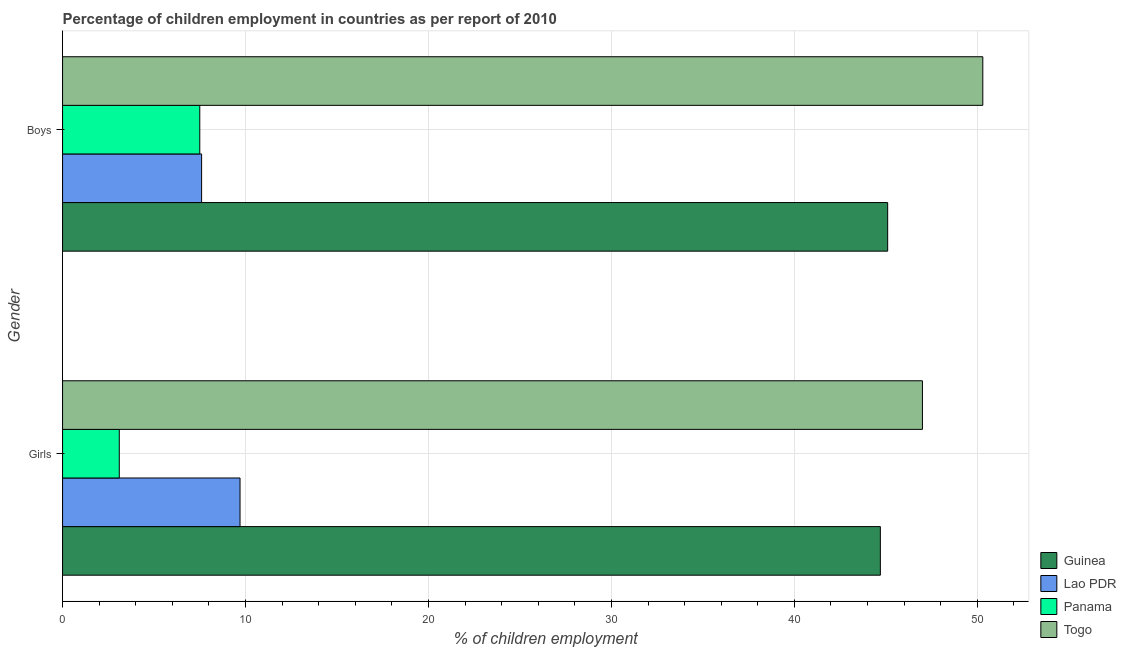Are the number of bars per tick equal to the number of legend labels?
Your response must be concise. Yes. Are the number of bars on each tick of the Y-axis equal?
Your answer should be very brief. Yes. How many bars are there on the 2nd tick from the top?
Your response must be concise. 4. What is the label of the 1st group of bars from the top?
Provide a short and direct response. Boys. What is the percentage of employed girls in Lao PDR?
Offer a terse response. 9.7. In which country was the percentage of employed boys maximum?
Your answer should be very brief. Togo. In which country was the percentage of employed girls minimum?
Provide a short and direct response. Panama. What is the total percentage of employed boys in the graph?
Keep it short and to the point. 110.5. What is the difference between the percentage of employed girls in Guinea and that in Lao PDR?
Ensure brevity in your answer.  35. What is the difference between the percentage of employed boys in Guinea and the percentage of employed girls in Lao PDR?
Your answer should be compact. 35.4. What is the average percentage of employed boys per country?
Offer a terse response. 27.62. What is the difference between the percentage of employed boys and percentage of employed girls in Lao PDR?
Offer a terse response. -2.1. In how many countries, is the percentage of employed boys greater than 10 %?
Ensure brevity in your answer.  2. What is the ratio of the percentage of employed girls in Panama to that in Guinea?
Ensure brevity in your answer.  0.07. What does the 1st bar from the top in Boys represents?
Your response must be concise. Togo. What does the 3rd bar from the bottom in Boys represents?
Offer a very short reply. Panama. Are all the bars in the graph horizontal?
Offer a very short reply. Yes. How many countries are there in the graph?
Make the answer very short. 4. Are the values on the major ticks of X-axis written in scientific E-notation?
Provide a succinct answer. No. Does the graph contain any zero values?
Give a very brief answer. No. Where does the legend appear in the graph?
Offer a very short reply. Bottom right. How many legend labels are there?
Provide a succinct answer. 4. How are the legend labels stacked?
Give a very brief answer. Vertical. What is the title of the graph?
Ensure brevity in your answer.  Percentage of children employment in countries as per report of 2010. Does "Bolivia" appear as one of the legend labels in the graph?
Give a very brief answer. No. What is the label or title of the X-axis?
Ensure brevity in your answer.  % of children employment. What is the % of children employment of Guinea in Girls?
Offer a very short reply. 44.7. What is the % of children employment of Lao PDR in Girls?
Provide a short and direct response. 9.7. What is the % of children employment of Togo in Girls?
Offer a very short reply. 47. What is the % of children employment in Guinea in Boys?
Your answer should be very brief. 45.1. What is the % of children employment in Lao PDR in Boys?
Give a very brief answer. 7.6. What is the % of children employment of Panama in Boys?
Offer a very short reply. 7.5. What is the % of children employment of Togo in Boys?
Keep it short and to the point. 50.3. Across all Gender, what is the maximum % of children employment in Guinea?
Offer a very short reply. 45.1. Across all Gender, what is the maximum % of children employment of Togo?
Give a very brief answer. 50.3. Across all Gender, what is the minimum % of children employment in Guinea?
Your response must be concise. 44.7. Across all Gender, what is the minimum % of children employment in Panama?
Provide a succinct answer. 3.1. Across all Gender, what is the minimum % of children employment of Togo?
Offer a terse response. 47. What is the total % of children employment in Guinea in the graph?
Provide a succinct answer. 89.8. What is the total % of children employment of Panama in the graph?
Ensure brevity in your answer.  10.6. What is the total % of children employment of Togo in the graph?
Keep it short and to the point. 97.3. What is the difference between the % of children employment in Guinea in Girls and that in Boys?
Provide a short and direct response. -0.4. What is the difference between the % of children employment of Lao PDR in Girls and that in Boys?
Ensure brevity in your answer.  2.1. What is the difference between the % of children employment in Togo in Girls and that in Boys?
Provide a short and direct response. -3.3. What is the difference between the % of children employment in Guinea in Girls and the % of children employment in Lao PDR in Boys?
Provide a succinct answer. 37.1. What is the difference between the % of children employment in Guinea in Girls and the % of children employment in Panama in Boys?
Make the answer very short. 37.2. What is the difference between the % of children employment of Guinea in Girls and the % of children employment of Togo in Boys?
Your response must be concise. -5.6. What is the difference between the % of children employment in Lao PDR in Girls and the % of children employment in Togo in Boys?
Ensure brevity in your answer.  -40.6. What is the difference between the % of children employment in Panama in Girls and the % of children employment in Togo in Boys?
Your response must be concise. -47.2. What is the average % of children employment in Guinea per Gender?
Offer a terse response. 44.9. What is the average % of children employment of Lao PDR per Gender?
Offer a very short reply. 8.65. What is the average % of children employment in Panama per Gender?
Your response must be concise. 5.3. What is the average % of children employment in Togo per Gender?
Provide a succinct answer. 48.65. What is the difference between the % of children employment of Guinea and % of children employment of Panama in Girls?
Make the answer very short. 41.6. What is the difference between the % of children employment of Lao PDR and % of children employment of Togo in Girls?
Your response must be concise. -37.3. What is the difference between the % of children employment of Panama and % of children employment of Togo in Girls?
Provide a short and direct response. -43.9. What is the difference between the % of children employment of Guinea and % of children employment of Lao PDR in Boys?
Provide a succinct answer. 37.5. What is the difference between the % of children employment of Guinea and % of children employment of Panama in Boys?
Keep it short and to the point. 37.6. What is the difference between the % of children employment in Guinea and % of children employment in Togo in Boys?
Ensure brevity in your answer.  -5.2. What is the difference between the % of children employment in Lao PDR and % of children employment in Togo in Boys?
Keep it short and to the point. -42.7. What is the difference between the % of children employment of Panama and % of children employment of Togo in Boys?
Offer a terse response. -42.8. What is the ratio of the % of children employment of Guinea in Girls to that in Boys?
Provide a succinct answer. 0.99. What is the ratio of the % of children employment of Lao PDR in Girls to that in Boys?
Make the answer very short. 1.28. What is the ratio of the % of children employment of Panama in Girls to that in Boys?
Provide a short and direct response. 0.41. What is the ratio of the % of children employment of Togo in Girls to that in Boys?
Keep it short and to the point. 0.93. What is the difference between the highest and the second highest % of children employment of Guinea?
Ensure brevity in your answer.  0.4. What is the difference between the highest and the second highest % of children employment in Lao PDR?
Offer a terse response. 2.1. What is the difference between the highest and the second highest % of children employment of Togo?
Your answer should be very brief. 3.3. What is the difference between the highest and the lowest % of children employment of Guinea?
Your response must be concise. 0.4. What is the difference between the highest and the lowest % of children employment of Panama?
Provide a succinct answer. 4.4. 